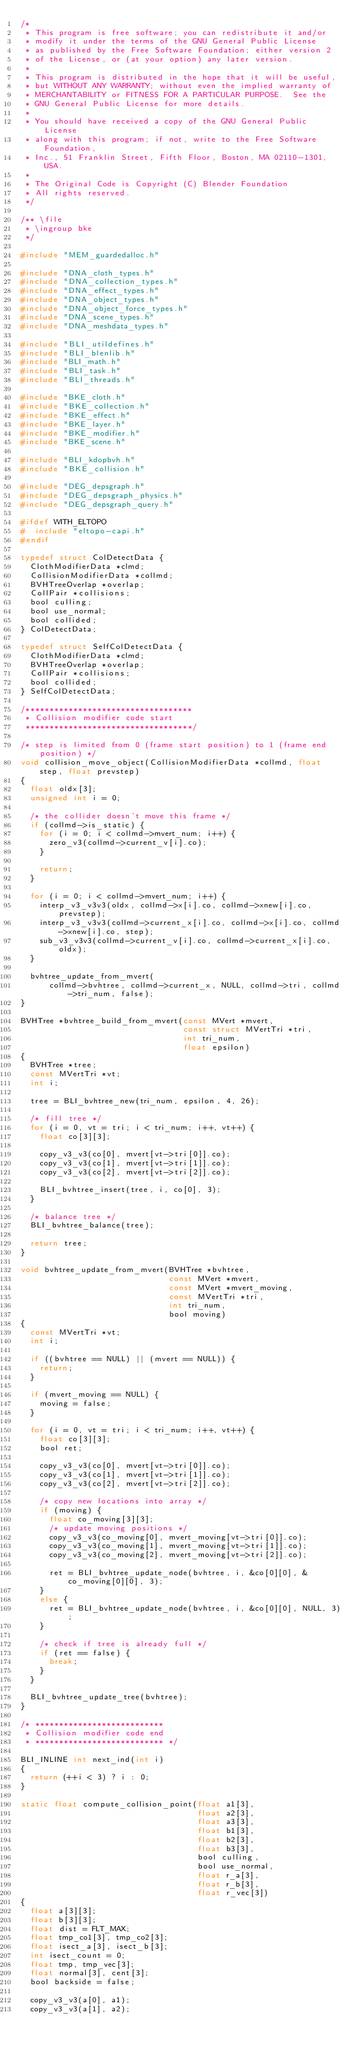Convert code to text. <code><loc_0><loc_0><loc_500><loc_500><_C_>/*
 * This program is free software; you can redistribute it and/or
 * modify it under the terms of the GNU General Public License
 * as published by the Free Software Foundation; either version 2
 * of the License, or (at your option) any later version.
 *
 * This program is distributed in the hope that it will be useful,
 * but WITHOUT ANY WARRANTY; without even the implied warranty of
 * MERCHANTABILITY or FITNESS FOR A PARTICULAR PURPOSE.  See the
 * GNU General Public License for more details.
 *
 * You should have received a copy of the GNU General Public License
 * along with this program; if not, write to the Free Software Foundation,
 * Inc., 51 Franklin Street, Fifth Floor, Boston, MA 02110-1301, USA.
 *
 * The Original Code is Copyright (C) Blender Foundation
 * All rights reserved.
 */

/** \file
 * \ingroup bke
 */

#include "MEM_guardedalloc.h"

#include "DNA_cloth_types.h"
#include "DNA_collection_types.h"
#include "DNA_effect_types.h"
#include "DNA_object_types.h"
#include "DNA_object_force_types.h"
#include "DNA_scene_types.h"
#include "DNA_meshdata_types.h"

#include "BLI_utildefines.h"
#include "BLI_blenlib.h"
#include "BLI_math.h"
#include "BLI_task.h"
#include "BLI_threads.h"

#include "BKE_cloth.h"
#include "BKE_collection.h"
#include "BKE_effect.h"
#include "BKE_layer.h"
#include "BKE_modifier.h"
#include "BKE_scene.h"

#include "BLI_kdopbvh.h"
#include "BKE_collision.h"

#include "DEG_depsgraph.h"
#include "DEG_depsgraph_physics.h"
#include "DEG_depsgraph_query.h"

#ifdef WITH_ELTOPO
#  include "eltopo-capi.h"
#endif

typedef struct ColDetectData {
  ClothModifierData *clmd;
  CollisionModifierData *collmd;
  BVHTreeOverlap *overlap;
  CollPair *collisions;
  bool culling;
  bool use_normal;
  bool collided;
} ColDetectData;

typedef struct SelfColDetectData {
  ClothModifierData *clmd;
  BVHTreeOverlap *overlap;
  CollPair *collisions;
  bool collided;
} SelfColDetectData;

/***********************************
 * Collision modifier code start
 ***********************************/

/* step is limited from 0 (frame start position) to 1 (frame end position) */
void collision_move_object(CollisionModifierData *collmd, float step, float prevstep)
{
  float oldx[3];
  unsigned int i = 0;

  /* the collider doesn't move this frame */
  if (collmd->is_static) {
    for (i = 0; i < collmd->mvert_num; i++) {
      zero_v3(collmd->current_v[i].co);
    }

    return;
  }

  for (i = 0; i < collmd->mvert_num; i++) {
    interp_v3_v3v3(oldx, collmd->x[i].co, collmd->xnew[i].co, prevstep);
    interp_v3_v3v3(collmd->current_x[i].co, collmd->x[i].co, collmd->xnew[i].co, step);
    sub_v3_v3v3(collmd->current_v[i].co, collmd->current_x[i].co, oldx);
  }

  bvhtree_update_from_mvert(
      collmd->bvhtree, collmd->current_x, NULL, collmd->tri, collmd->tri_num, false);
}

BVHTree *bvhtree_build_from_mvert(const MVert *mvert,
                                  const struct MVertTri *tri,
                                  int tri_num,
                                  float epsilon)
{
  BVHTree *tree;
  const MVertTri *vt;
  int i;

  tree = BLI_bvhtree_new(tri_num, epsilon, 4, 26);

  /* fill tree */
  for (i = 0, vt = tri; i < tri_num; i++, vt++) {
    float co[3][3];

    copy_v3_v3(co[0], mvert[vt->tri[0]].co);
    copy_v3_v3(co[1], mvert[vt->tri[1]].co);
    copy_v3_v3(co[2], mvert[vt->tri[2]].co);

    BLI_bvhtree_insert(tree, i, co[0], 3);
  }

  /* balance tree */
  BLI_bvhtree_balance(tree);

  return tree;
}

void bvhtree_update_from_mvert(BVHTree *bvhtree,
                               const MVert *mvert,
                               const MVert *mvert_moving,
                               const MVertTri *tri,
                               int tri_num,
                               bool moving)
{
  const MVertTri *vt;
  int i;

  if ((bvhtree == NULL) || (mvert == NULL)) {
    return;
  }

  if (mvert_moving == NULL) {
    moving = false;
  }

  for (i = 0, vt = tri; i < tri_num; i++, vt++) {
    float co[3][3];
    bool ret;

    copy_v3_v3(co[0], mvert[vt->tri[0]].co);
    copy_v3_v3(co[1], mvert[vt->tri[1]].co);
    copy_v3_v3(co[2], mvert[vt->tri[2]].co);

    /* copy new locations into array */
    if (moving) {
      float co_moving[3][3];
      /* update moving positions */
      copy_v3_v3(co_moving[0], mvert_moving[vt->tri[0]].co);
      copy_v3_v3(co_moving[1], mvert_moving[vt->tri[1]].co);
      copy_v3_v3(co_moving[2], mvert_moving[vt->tri[2]].co);

      ret = BLI_bvhtree_update_node(bvhtree, i, &co[0][0], &co_moving[0][0], 3);
    }
    else {
      ret = BLI_bvhtree_update_node(bvhtree, i, &co[0][0], NULL, 3);
    }

    /* check if tree is already full */
    if (ret == false) {
      break;
    }
  }

  BLI_bvhtree_update_tree(bvhtree);
}

/* ***************************
 * Collision modifier code end
 * *************************** */

BLI_INLINE int next_ind(int i)
{
  return (++i < 3) ? i : 0;
}

static float compute_collision_point(float a1[3],
                                     float a2[3],
                                     float a3[3],
                                     float b1[3],
                                     float b2[3],
                                     float b3[3],
                                     bool culling,
                                     bool use_normal,
                                     float r_a[3],
                                     float r_b[3],
                                     float r_vec[3])
{
  float a[3][3];
  float b[3][3];
  float dist = FLT_MAX;
  float tmp_co1[3], tmp_co2[3];
  float isect_a[3], isect_b[3];
  int isect_count = 0;
  float tmp, tmp_vec[3];
  float normal[3], cent[3];
  bool backside = false;

  copy_v3_v3(a[0], a1);
  copy_v3_v3(a[1], a2);</code> 